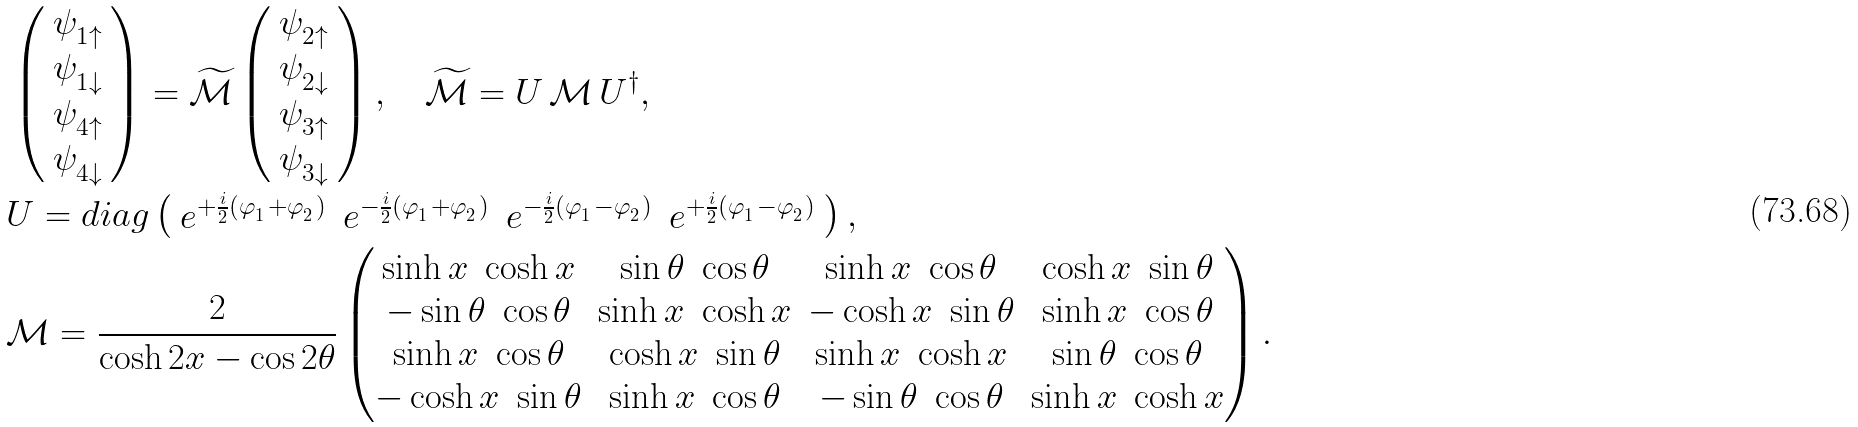Convert formula to latex. <formula><loc_0><loc_0><loc_500><loc_500>& \left ( \begin{array} { c } \psi ^ { \ } _ { 1 \uparrow } \\ \psi ^ { \ } _ { 1 \downarrow } \\ \psi ^ { \ } _ { 4 \uparrow } \\ \psi ^ { \ } _ { 4 \downarrow } \end{array} \right ) = \widetilde { \mathcal { M } } \left ( \begin{array} { c } \psi ^ { \ } _ { 2 \uparrow } \\ \psi ^ { \ } _ { 2 \downarrow } \\ \psi ^ { \ } _ { 3 \uparrow } \\ \psi ^ { \ } _ { 3 \downarrow } \end{array} \right ) , \quad \widetilde { \mathcal { M } } = U \, \mathcal { M } \, U ^ { \dag } , \\ & U = d i a g \left ( \begin{array} { c c c c } e ^ { + \frac { i } { 2 } ( \varphi ^ { \ } _ { 1 } + \varphi ^ { \ } _ { 2 } ) } & e ^ { - \frac { i } { 2 } ( \varphi ^ { \ } _ { 1 } + \varphi ^ { \ } _ { 2 } ) } & e ^ { - \frac { i } { 2 } ( \varphi ^ { \ } _ { 1 } - \varphi ^ { \ } _ { 2 } ) } & e ^ { + \frac { i } { 2 } ( \varphi ^ { \ } _ { 1 } - \varphi ^ { \ } _ { 2 } ) } \end{array} \right ) , \\ & \mathcal { M } = \frac { 2 } { \cosh 2 x - \cos 2 \theta } \begin{pmatrix} \sinh x \ \cosh x & \sin \theta \ \cos \theta & \sinh x \ \cos \theta & \cosh x \ \sin \theta \\ - \sin \theta \ \cos \theta & \sinh x \ \cosh x & - \cosh x \ \sin \theta & \sinh x \ \cos \theta \\ \sinh x \ \cos \theta & \cosh x \ \sin \theta & \sinh x \ \cosh x & \sin \theta \ \cos \theta \\ - \cosh x \ \sin \theta & \sinh x \ \cos \theta & - \sin \theta \ \cos \theta & \sinh x \ \cosh x \end{pmatrix} .</formula> 